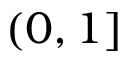Convert formula to latex. <formula><loc_0><loc_0><loc_500><loc_500>( 0 , 1 ]</formula> 